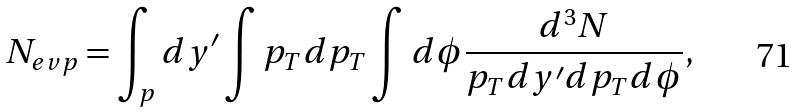Convert formula to latex. <formula><loc_0><loc_0><loc_500><loc_500>N _ { e v p } = \int _ { p } d y ^ { \prime } \int p _ { T } d p _ { T } \int d \phi { \frac { d ^ { 3 } N } { p _ { T } d y ^ { \prime } d p _ { T } d \phi } } ,</formula> 